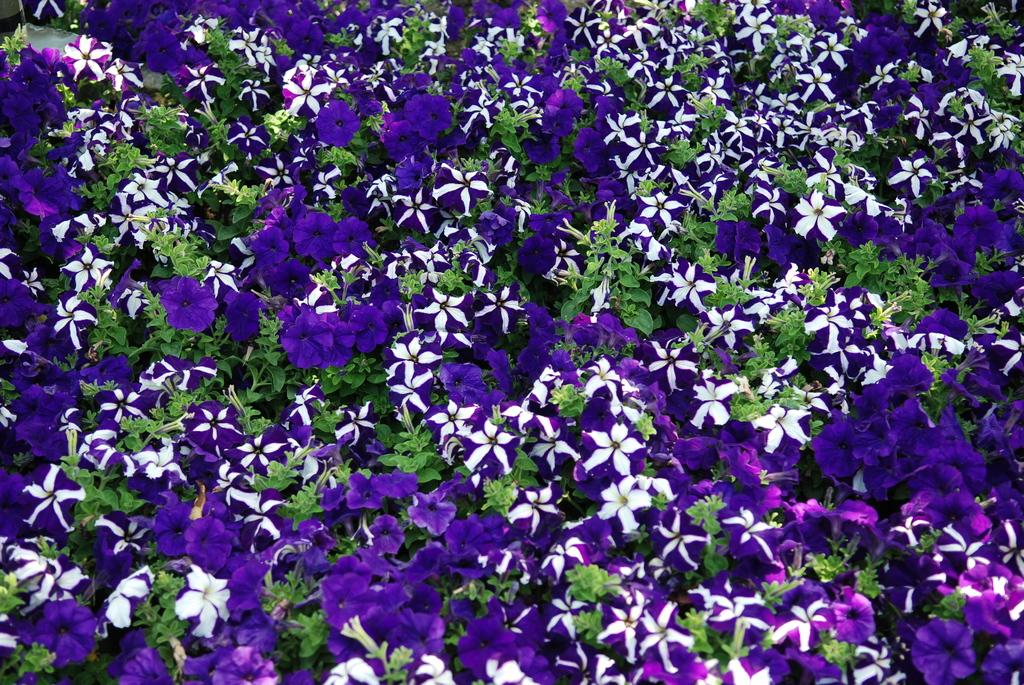What type of plants can be seen in the image? There are colorful flowers and green leaves in the image. Can you describe the colors of the flowers? The flowers in the image are colorful, but the specific colors are not mentioned in the facts. What is the color of the leaves in the image? The leaves in the image are green. What type of plane can be seen flying over the flowers in the image? There is no plane visible in the image; it only features flowers and leaves. How much sugar is present in the flowers in the image? The facts do not mention anything about sugar being present in the flowers, so we cannot determine the amount. 